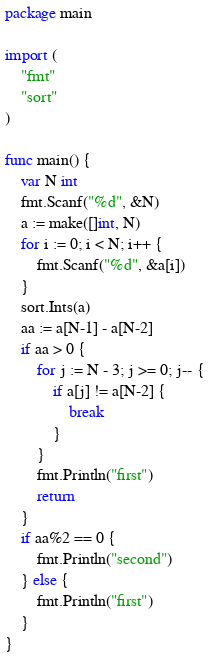Convert code to text. <code><loc_0><loc_0><loc_500><loc_500><_Go_>package main

import (
	"fmt"
	"sort"
)

func main() {
	var N int
	fmt.Scanf("%d", &N)
	a := make([]int, N)
	for i := 0; i < N; i++ {
		fmt.Scanf("%d", &a[i])
	}
	sort.Ints(a)
	aa := a[N-1] - a[N-2]
	if aa > 0 {
		for j := N - 3; j >= 0; j-- {
			if a[j] != a[N-2] {
				break
			}
		}
		fmt.Println("first")
		return
	}
	if aa%2 == 0 {
		fmt.Println("second")
	} else {
		fmt.Println("first")
	}
}
</code> 